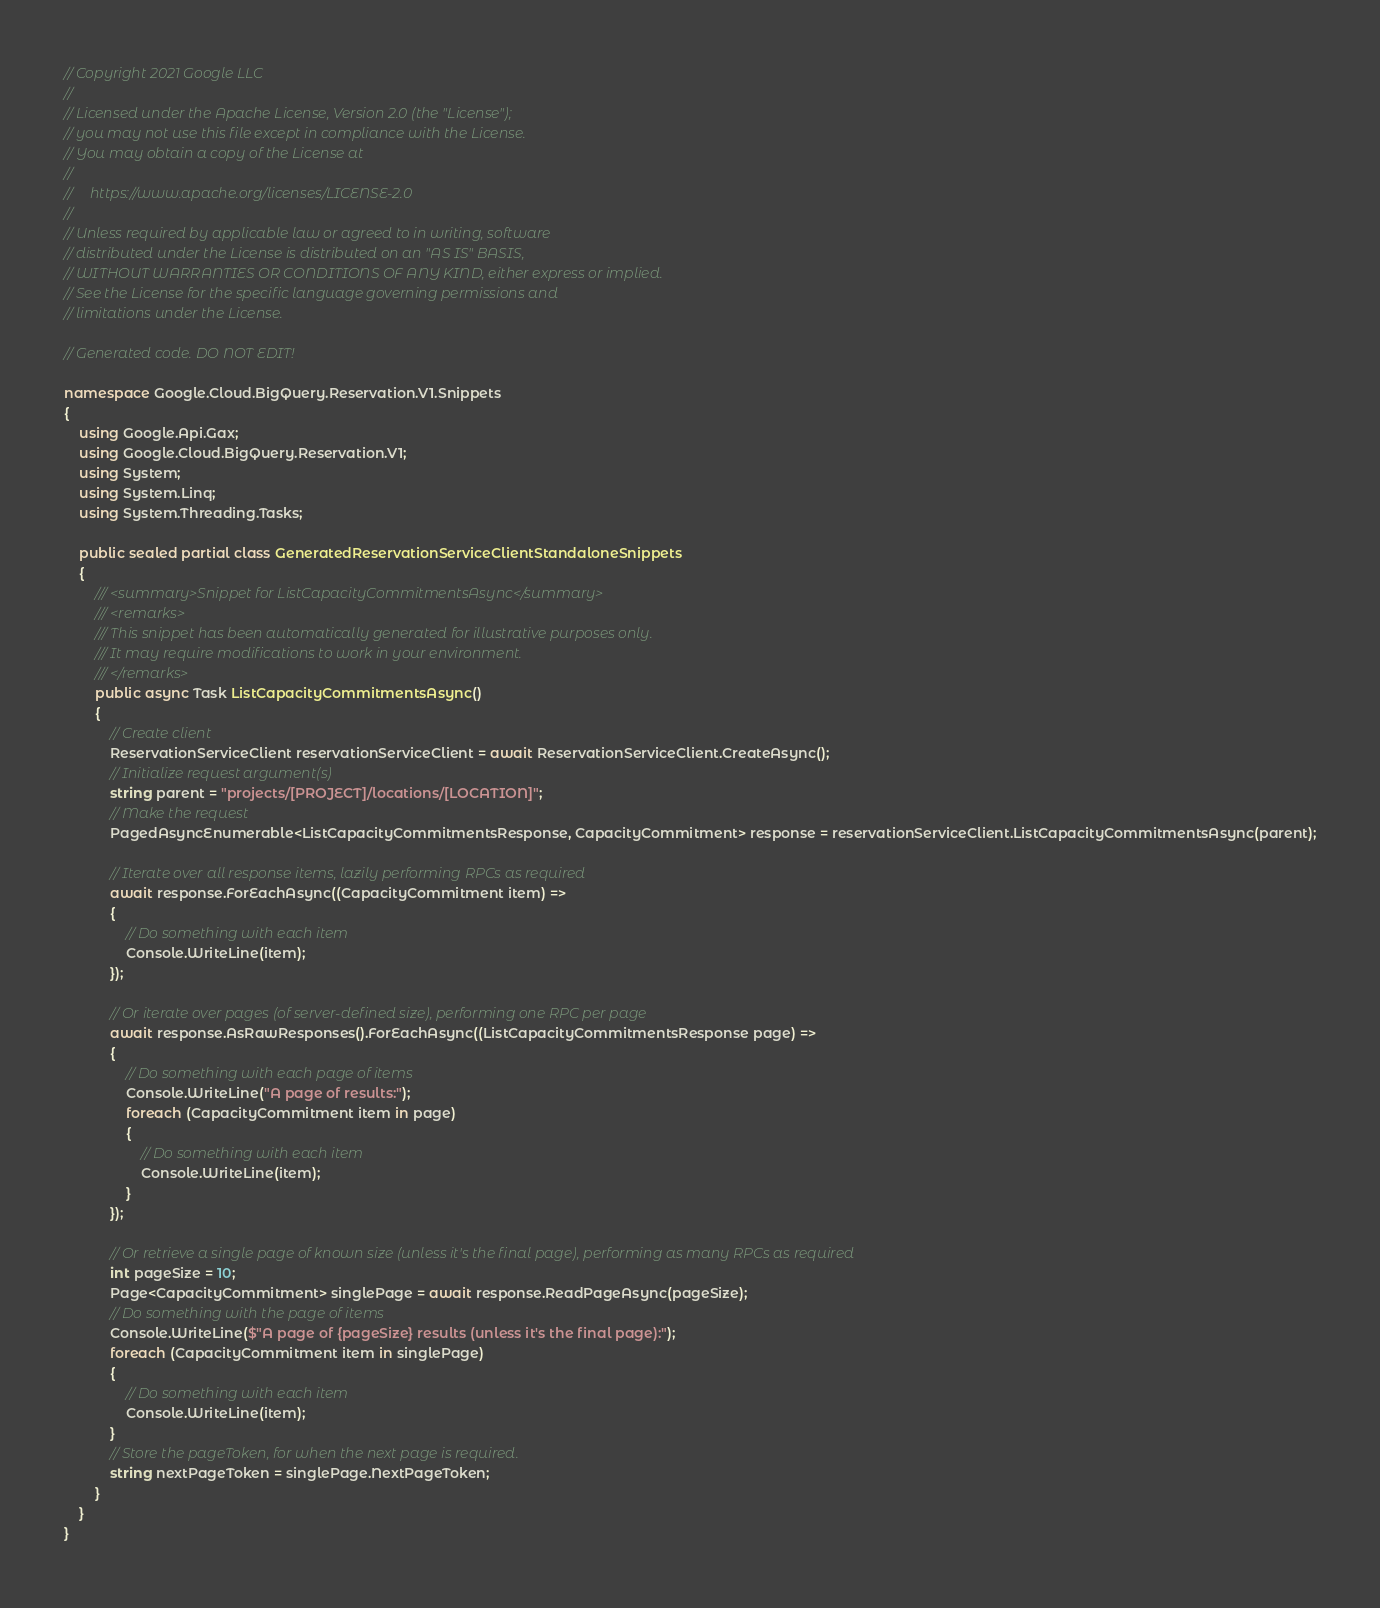<code> <loc_0><loc_0><loc_500><loc_500><_C#_>// Copyright 2021 Google LLC
//
// Licensed under the Apache License, Version 2.0 (the "License");
// you may not use this file except in compliance with the License.
// You may obtain a copy of the License at
//
//     https://www.apache.org/licenses/LICENSE-2.0
//
// Unless required by applicable law or agreed to in writing, software
// distributed under the License is distributed on an "AS IS" BASIS,
// WITHOUT WARRANTIES OR CONDITIONS OF ANY KIND, either express or implied.
// See the License for the specific language governing permissions and
// limitations under the License.

// Generated code. DO NOT EDIT!

namespace Google.Cloud.BigQuery.Reservation.V1.Snippets
{
    using Google.Api.Gax;
    using Google.Cloud.BigQuery.Reservation.V1;
    using System;
    using System.Linq;
    using System.Threading.Tasks;

    public sealed partial class GeneratedReservationServiceClientStandaloneSnippets
    {
        /// <summary>Snippet for ListCapacityCommitmentsAsync</summary>
        /// <remarks>
        /// This snippet has been automatically generated for illustrative purposes only.
        /// It may require modifications to work in your environment.
        /// </remarks>
        public async Task ListCapacityCommitmentsAsync()
        {
            // Create client
            ReservationServiceClient reservationServiceClient = await ReservationServiceClient.CreateAsync();
            // Initialize request argument(s)
            string parent = "projects/[PROJECT]/locations/[LOCATION]";
            // Make the request
            PagedAsyncEnumerable<ListCapacityCommitmentsResponse, CapacityCommitment> response = reservationServiceClient.ListCapacityCommitmentsAsync(parent);

            // Iterate over all response items, lazily performing RPCs as required
            await response.ForEachAsync((CapacityCommitment item) =>
            {
                // Do something with each item
                Console.WriteLine(item);
            });

            // Or iterate over pages (of server-defined size), performing one RPC per page
            await response.AsRawResponses().ForEachAsync((ListCapacityCommitmentsResponse page) =>
            {
                // Do something with each page of items
                Console.WriteLine("A page of results:");
                foreach (CapacityCommitment item in page)
                {
                    // Do something with each item
                    Console.WriteLine(item);
                }
            });

            // Or retrieve a single page of known size (unless it's the final page), performing as many RPCs as required
            int pageSize = 10;
            Page<CapacityCommitment> singlePage = await response.ReadPageAsync(pageSize);
            // Do something with the page of items
            Console.WriteLine($"A page of {pageSize} results (unless it's the final page):");
            foreach (CapacityCommitment item in singlePage)
            {
                // Do something with each item
                Console.WriteLine(item);
            }
            // Store the pageToken, for when the next page is required.
            string nextPageToken = singlePage.NextPageToken;
        }
    }
}
</code> 